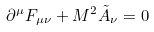Convert formula to latex. <formula><loc_0><loc_0><loc_500><loc_500>\partial ^ { \mu } F _ { \mu \nu } + M ^ { 2 } \tilde { A } _ { \nu } = 0</formula> 